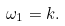<formula> <loc_0><loc_0><loc_500><loc_500>\omega _ { 1 } = k .</formula> 